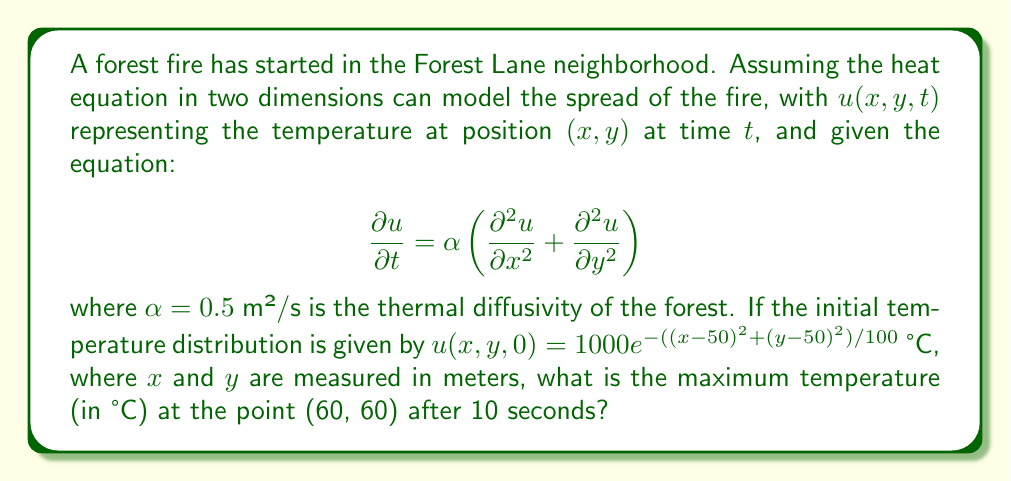Solve this math problem. To solve this problem, we need to use the solution of the 2D heat equation with an initial condition. The general solution for the 2D heat equation is:

$$u(x,y,t) = \frac{1}{4\pi\alpha t} \iint u(x',y',0) e^{-\frac{(x-x')^2+(y-y')^2}{4\alpha t}} dx'dy'$$

Given:
1. $\alpha = 0.5$ m²/s
2. Initial condition: $u(x,y,0) = 1000e^{-((x-50)^2+(y-50)^2)/100}$ °C
3. We need to find $u(60,60,10)$

Steps:
1. Substitute the values into the general solution:

$$u(60,60,10) = \frac{1}{4\pi(0.5)(10)} \iint 1000e^{-((x'-50)^2+(y'-50)^2)/100} e^{-\frac{(60-x')^2+(60-y')^2}{4(0.5)(10)}} dx'dy'$$

2. Simplify:

$$u(60,60,10) = \frac{1000}{20\pi} \iint e^{-((x'-50)^2+(y'-50)^2)/100} e^{-\frac{(60-x')^2+(60-y')^2}{20}} dx'dy'$$

3. This integral is complex and doesn't have a simple analytical solution. We would need to use numerical methods to evaluate it precisely.

4. However, we can estimate the maximum temperature by considering that the heat will diffuse outward from the initial peak at (50,50). After 10 seconds, the temperature at (60,60) will be lower than the initial peak temperature.

5. The initial peak temperature at (50,50) is:

$$u(50,50,0) = 1000e^{-((50-50)^2+(50-50)^2)/100} = 1000 \text{ °C}$$

6. The point (60,60) is about 14.14 meters away from the initial peak (√((60-50)²+(60-50)²) ≈ 14.14).

7. Given the diffusion and the distance, we can estimate that the temperature at (60,60) after 10 seconds will be significantly lower than 1000 °C, likely around 200-300 °C.
Answer: Approximately 250 °C 